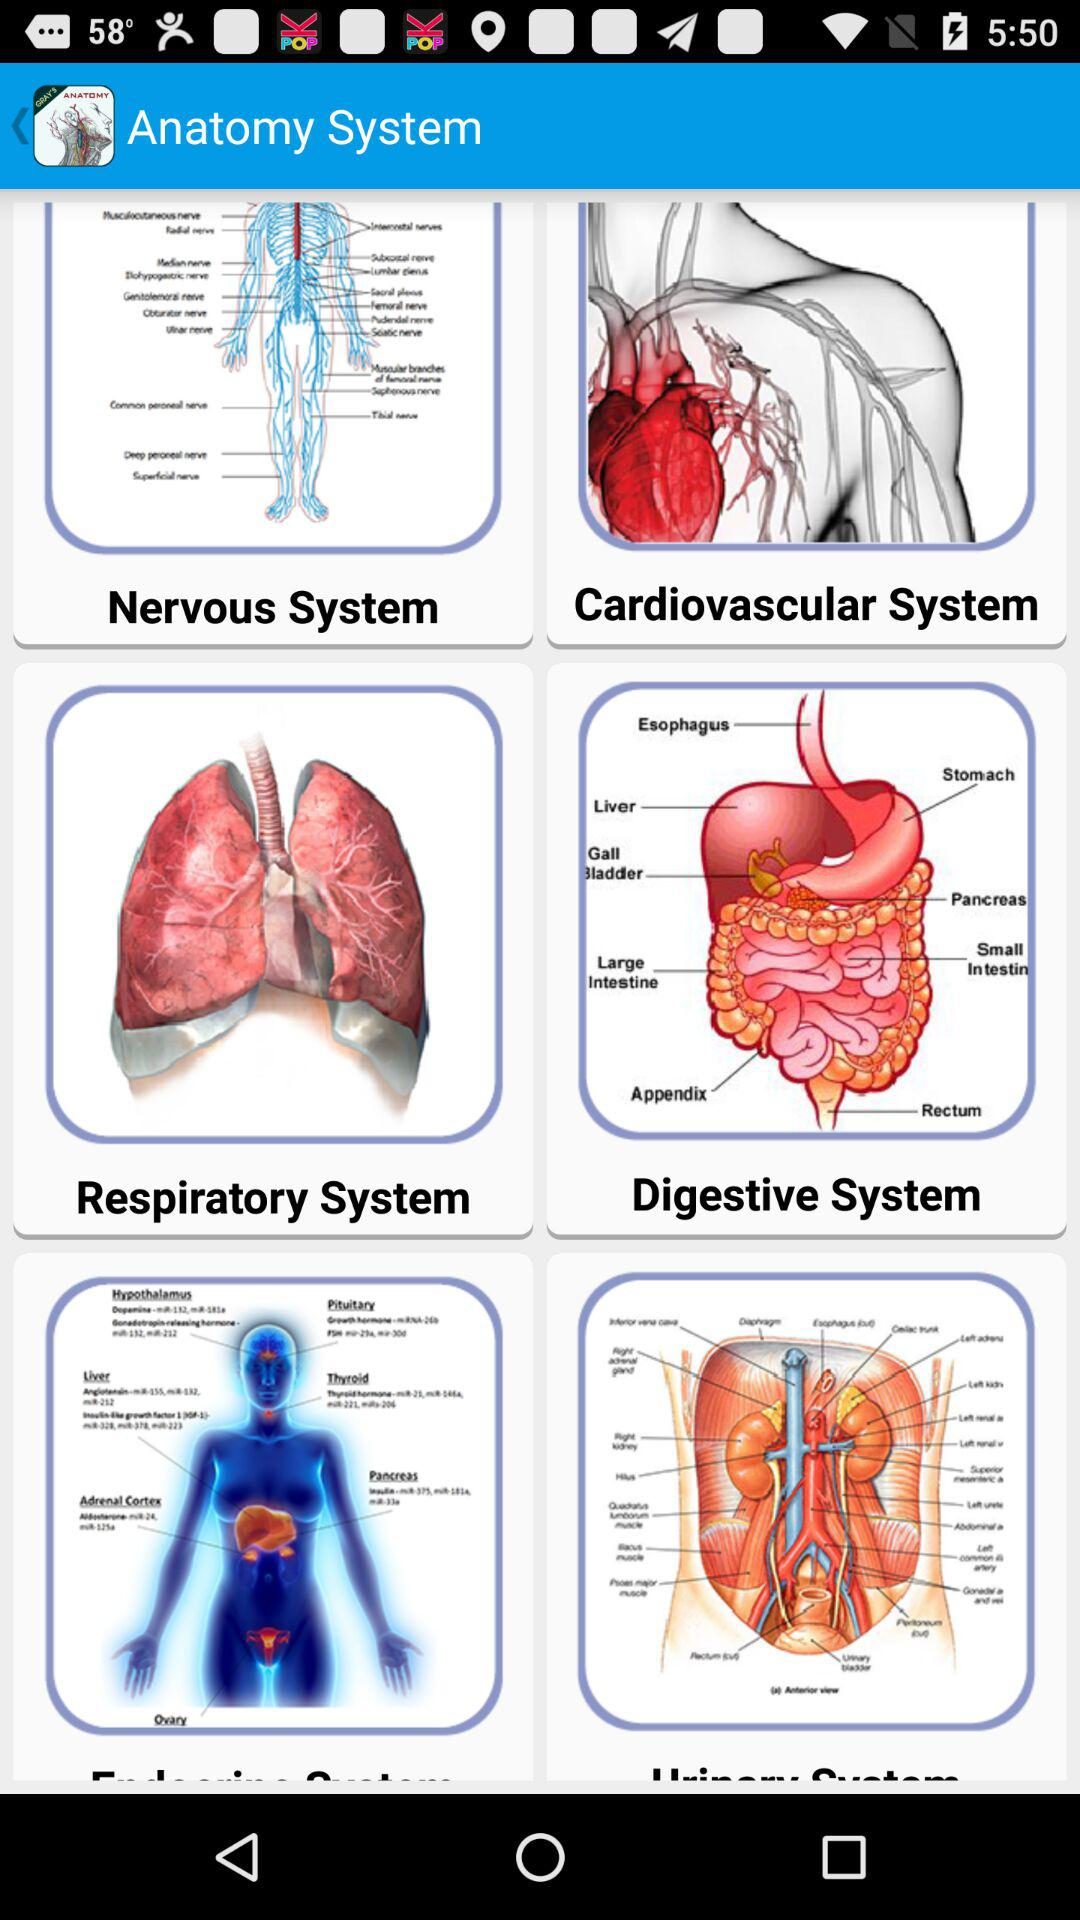What are the different systems available in "Anatomy System"? The different systems available in "Anatomy System" are the "Nervous System", "Cardiovascular System", "Respiratory System" and "Digestive System". 